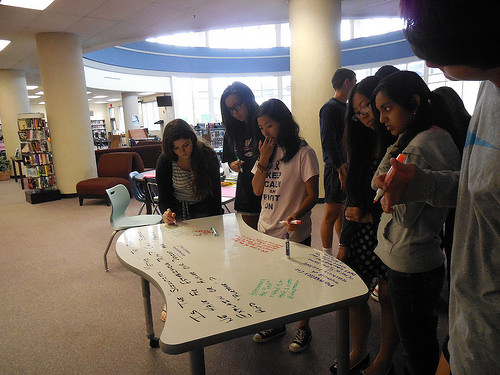<image>
Is the table in front of the chair? No. The table is not in front of the chair. The spatial positioning shows a different relationship between these objects. 